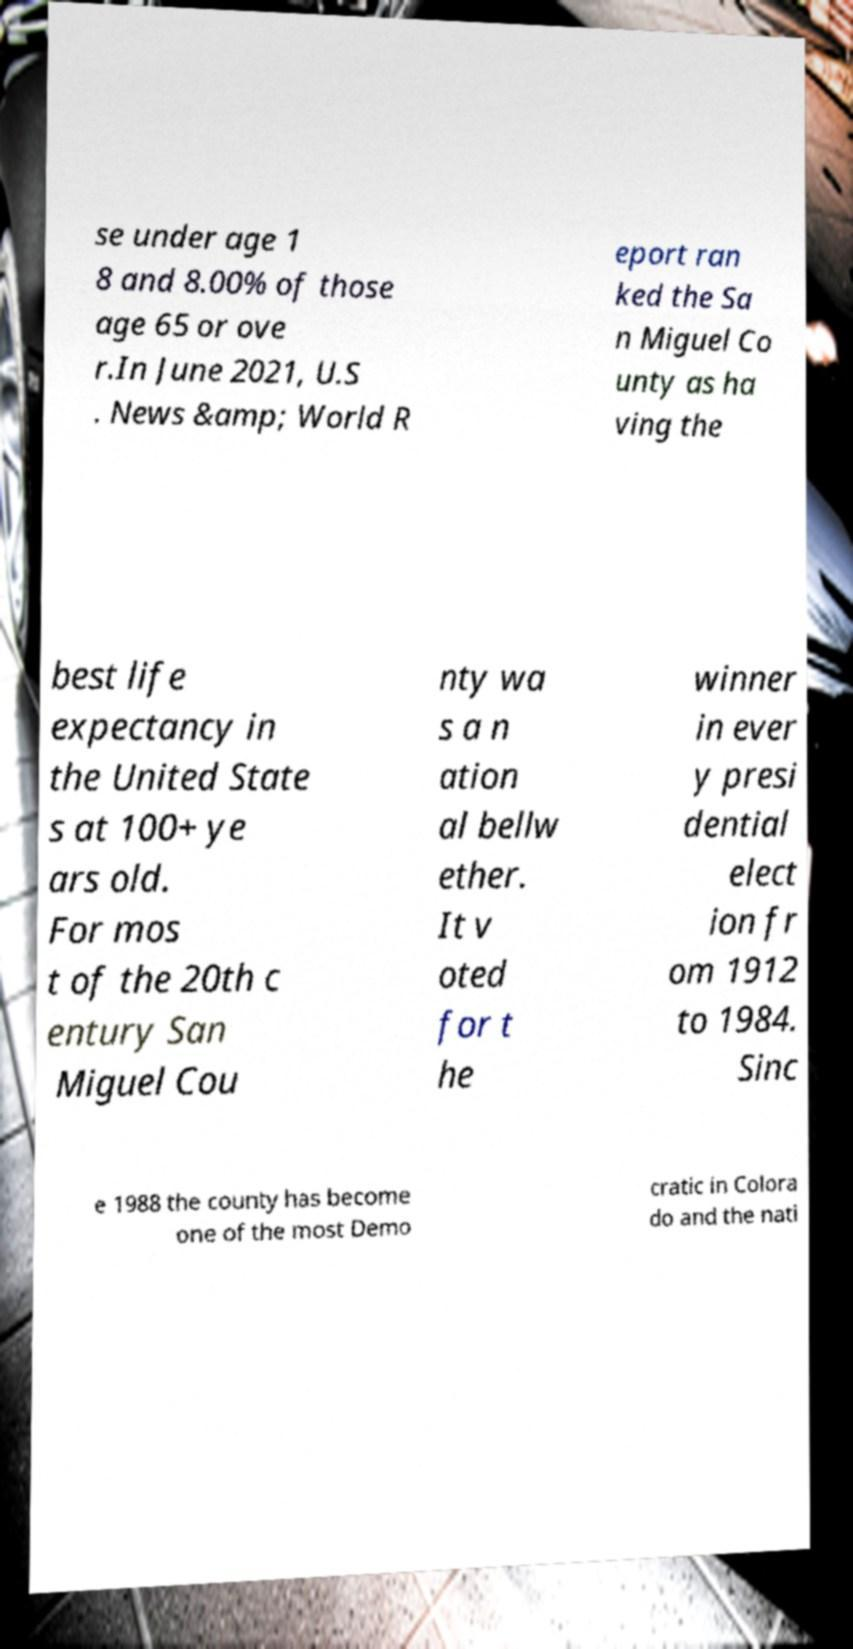Please identify and transcribe the text found in this image. se under age 1 8 and 8.00% of those age 65 or ove r.In June 2021, U.S . News &amp; World R eport ran ked the Sa n Miguel Co unty as ha ving the best life expectancy in the United State s at 100+ ye ars old. For mos t of the 20th c entury San Miguel Cou nty wa s a n ation al bellw ether. It v oted for t he winner in ever y presi dential elect ion fr om 1912 to 1984. Sinc e 1988 the county has become one of the most Demo cratic in Colora do and the nati 